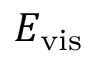Convert formula to latex. <formula><loc_0><loc_0><loc_500><loc_500>E _ { v i s }</formula> 